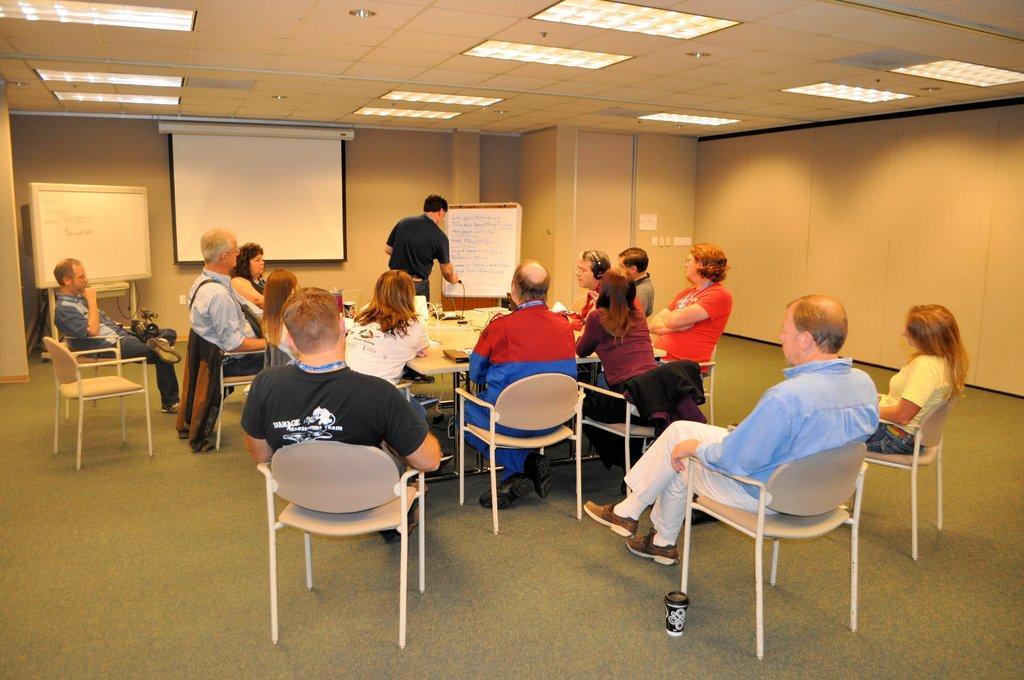How would you summarize this image in a sentence or two? In this picture we can see a group of people sitting on chair and one person is explaining something on the board and in the background we can see screen and other board,wall, pipe,lights and beside to this man chair there is a glass. 